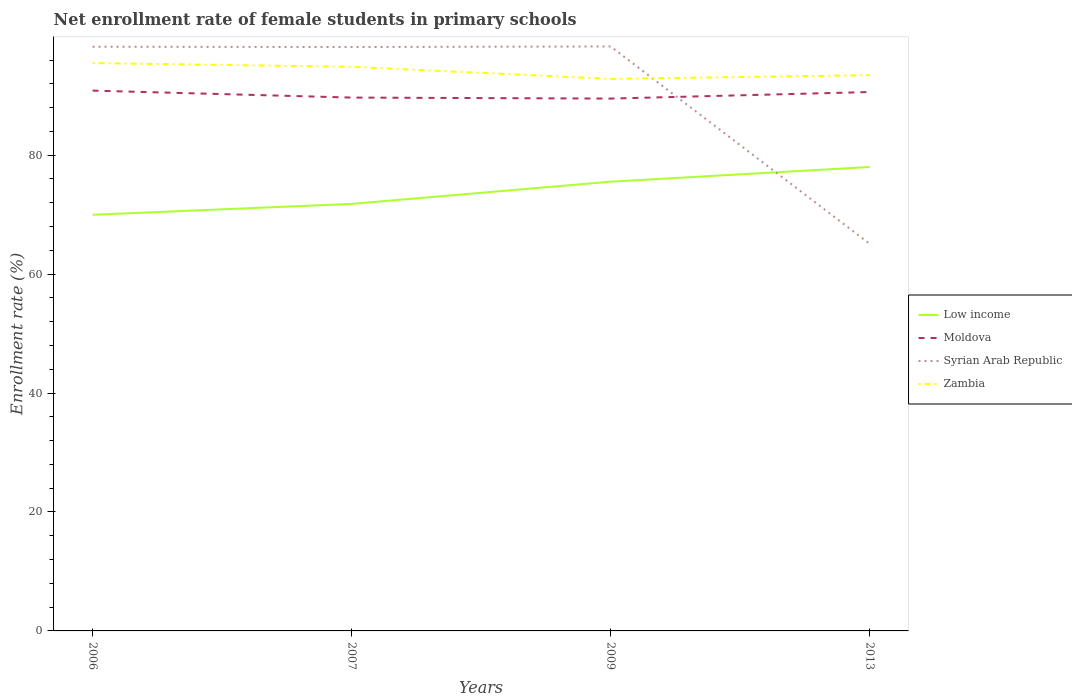Across all years, what is the maximum net enrollment rate of female students in primary schools in Zambia?
Provide a succinct answer. 92.83. In which year was the net enrollment rate of female students in primary schools in Low income maximum?
Ensure brevity in your answer.  2006. What is the total net enrollment rate of female students in primary schools in Moldova in the graph?
Keep it short and to the point. -1.1. What is the difference between the highest and the second highest net enrollment rate of female students in primary schools in Low income?
Provide a succinct answer. 8.03. What is the difference between the highest and the lowest net enrollment rate of female students in primary schools in Syrian Arab Republic?
Your answer should be compact. 3. Is the net enrollment rate of female students in primary schools in Moldova strictly greater than the net enrollment rate of female students in primary schools in Syrian Arab Republic over the years?
Offer a terse response. No. How many lines are there?
Ensure brevity in your answer.  4. What is the difference between two consecutive major ticks on the Y-axis?
Make the answer very short. 20. Does the graph contain any zero values?
Ensure brevity in your answer.  No. Does the graph contain grids?
Offer a very short reply. No. How many legend labels are there?
Give a very brief answer. 4. What is the title of the graph?
Give a very brief answer. Net enrollment rate of female students in primary schools. What is the label or title of the X-axis?
Your answer should be compact. Years. What is the label or title of the Y-axis?
Ensure brevity in your answer.  Enrollment rate (%). What is the Enrollment rate (%) of Low income in 2006?
Give a very brief answer. 69.98. What is the Enrollment rate (%) of Moldova in 2006?
Offer a terse response. 90.86. What is the Enrollment rate (%) in Syrian Arab Republic in 2006?
Make the answer very short. 98.23. What is the Enrollment rate (%) in Zambia in 2006?
Ensure brevity in your answer.  95.49. What is the Enrollment rate (%) of Low income in 2007?
Your answer should be compact. 71.81. What is the Enrollment rate (%) of Moldova in 2007?
Your response must be concise. 89.69. What is the Enrollment rate (%) in Syrian Arab Republic in 2007?
Your response must be concise. 98.18. What is the Enrollment rate (%) in Zambia in 2007?
Ensure brevity in your answer.  94.86. What is the Enrollment rate (%) in Low income in 2009?
Your answer should be compact. 75.54. What is the Enrollment rate (%) of Moldova in 2009?
Offer a very short reply. 89.52. What is the Enrollment rate (%) of Syrian Arab Republic in 2009?
Make the answer very short. 98.28. What is the Enrollment rate (%) in Zambia in 2009?
Give a very brief answer. 92.83. What is the Enrollment rate (%) of Low income in 2013?
Provide a short and direct response. 78.01. What is the Enrollment rate (%) in Moldova in 2013?
Ensure brevity in your answer.  90.62. What is the Enrollment rate (%) of Syrian Arab Republic in 2013?
Your answer should be very brief. 65.09. What is the Enrollment rate (%) of Zambia in 2013?
Provide a succinct answer. 93.46. Across all years, what is the maximum Enrollment rate (%) of Low income?
Your answer should be very brief. 78.01. Across all years, what is the maximum Enrollment rate (%) in Moldova?
Offer a very short reply. 90.86. Across all years, what is the maximum Enrollment rate (%) of Syrian Arab Republic?
Make the answer very short. 98.28. Across all years, what is the maximum Enrollment rate (%) of Zambia?
Offer a very short reply. 95.49. Across all years, what is the minimum Enrollment rate (%) in Low income?
Offer a very short reply. 69.98. Across all years, what is the minimum Enrollment rate (%) of Moldova?
Give a very brief answer. 89.52. Across all years, what is the minimum Enrollment rate (%) of Syrian Arab Republic?
Your answer should be very brief. 65.09. Across all years, what is the minimum Enrollment rate (%) in Zambia?
Your answer should be compact. 92.83. What is the total Enrollment rate (%) in Low income in the graph?
Ensure brevity in your answer.  295.34. What is the total Enrollment rate (%) of Moldova in the graph?
Offer a very short reply. 360.67. What is the total Enrollment rate (%) in Syrian Arab Republic in the graph?
Offer a terse response. 359.79. What is the total Enrollment rate (%) in Zambia in the graph?
Make the answer very short. 376.64. What is the difference between the Enrollment rate (%) in Low income in 2006 and that in 2007?
Your answer should be compact. -1.83. What is the difference between the Enrollment rate (%) of Moldova in 2006 and that in 2007?
Make the answer very short. 1.17. What is the difference between the Enrollment rate (%) in Syrian Arab Republic in 2006 and that in 2007?
Your answer should be very brief. 0.05. What is the difference between the Enrollment rate (%) in Zambia in 2006 and that in 2007?
Make the answer very short. 0.64. What is the difference between the Enrollment rate (%) in Low income in 2006 and that in 2009?
Offer a very short reply. -5.56. What is the difference between the Enrollment rate (%) of Moldova in 2006 and that in 2009?
Offer a very short reply. 1.34. What is the difference between the Enrollment rate (%) in Syrian Arab Republic in 2006 and that in 2009?
Make the answer very short. -0.05. What is the difference between the Enrollment rate (%) of Zambia in 2006 and that in 2009?
Your answer should be compact. 2.67. What is the difference between the Enrollment rate (%) in Low income in 2006 and that in 2013?
Your answer should be compact. -8.03. What is the difference between the Enrollment rate (%) of Moldova in 2006 and that in 2013?
Provide a succinct answer. 0.24. What is the difference between the Enrollment rate (%) in Syrian Arab Republic in 2006 and that in 2013?
Provide a short and direct response. 33.14. What is the difference between the Enrollment rate (%) of Zambia in 2006 and that in 2013?
Your response must be concise. 2.04. What is the difference between the Enrollment rate (%) in Low income in 2007 and that in 2009?
Offer a very short reply. -3.74. What is the difference between the Enrollment rate (%) of Moldova in 2007 and that in 2009?
Your answer should be compact. 0.17. What is the difference between the Enrollment rate (%) in Syrian Arab Republic in 2007 and that in 2009?
Provide a succinct answer. -0.1. What is the difference between the Enrollment rate (%) of Zambia in 2007 and that in 2009?
Offer a very short reply. 2.03. What is the difference between the Enrollment rate (%) of Low income in 2007 and that in 2013?
Give a very brief answer. -6.21. What is the difference between the Enrollment rate (%) in Moldova in 2007 and that in 2013?
Give a very brief answer. -0.93. What is the difference between the Enrollment rate (%) in Syrian Arab Republic in 2007 and that in 2013?
Keep it short and to the point. 33.09. What is the difference between the Enrollment rate (%) in Zambia in 2007 and that in 2013?
Provide a succinct answer. 1.4. What is the difference between the Enrollment rate (%) of Low income in 2009 and that in 2013?
Keep it short and to the point. -2.47. What is the difference between the Enrollment rate (%) in Moldova in 2009 and that in 2013?
Provide a succinct answer. -1.1. What is the difference between the Enrollment rate (%) of Syrian Arab Republic in 2009 and that in 2013?
Give a very brief answer. 33.19. What is the difference between the Enrollment rate (%) in Zambia in 2009 and that in 2013?
Make the answer very short. -0.63. What is the difference between the Enrollment rate (%) in Low income in 2006 and the Enrollment rate (%) in Moldova in 2007?
Provide a short and direct response. -19.71. What is the difference between the Enrollment rate (%) of Low income in 2006 and the Enrollment rate (%) of Syrian Arab Republic in 2007?
Provide a short and direct response. -28.2. What is the difference between the Enrollment rate (%) in Low income in 2006 and the Enrollment rate (%) in Zambia in 2007?
Your answer should be compact. -24.88. What is the difference between the Enrollment rate (%) of Moldova in 2006 and the Enrollment rate (%) of Syrian Arab Republic in 2007?
Your response must be concise. -7.33. What is the difference between the Enrollment rate (%) of Moldova in 2006 and the Enrollment rate (%) of Zambia in 2007?
Provide a short and direct response. -4. What is the difference between the Enrollment rate (%) of Syrian Arab Republic in 2006 and the Enrollment rate (%) of Zambia in 2007?
Offer a terse response. 3.38. What is the difference between the Enrollment rate (%) in Low income in 2006 and the Enrollment rate (%) in Moldova in 2009?
Ensure brevity in your answer.  -19.54. What is the difference between the Enrollment rate (%) of Low income in 2006 and the Enrollment rate (%) of Syrian Arab Republic in 2009?
Ensure brevity in your answer.  -28.3. What is the difference between the Enrollment rate (%) of Low income in 2006 and the Enrollment rate (%) of Zambia in 2009?
Ensure brevity in your answer.  -22.85. What is the difference between the Enrollment rate (%) in Moldova in 2006 and the Enrollment rate (%) in Syrian Arab Republic in 2009?
Your answer should be very brief. -7.43. What is the difference between the Enrollment rate (%) of Moldova in 2006 and the Enrollment rate (%) of Zambia in 2009?
Provide a short and direct response. -1.97. What is the difference between the Enrollment rate (%) of Syrian Arab Republic in 2006 and the Enrollment rate (%) of Zambia in 2009?
Give a very brief answer. 5.41. What is the difference between the Enrollment rate (%) in Low income in 2006 and the Enrollment rate (%) in Moldova in 2013?
Make the answer very short. -20.64. What is the difference between the Enrollment rate (%) in Low income in 2006 and the Enrollment rate (%) in Syrian Arab Republic in 2013?
Your answer should be very brief. 4.89. What is the difference between the Enrollment rate (%) in Low income in 2006 and the Enrollment rate (%) in Zambia in 2013?
Give a very brief answer. -23.48. What is the difference between the Enrollment rate (%) in Moldova in 2006 and the Enrollment rate (%) in Syrian Arab Republic in 2013?
Provide a succinct answer. 25.76. What is the difference between the Enrollment rate (%) of Moldova in 2006 and the Enrollment rate (%) of Zambia in 2013?
Offer a very short reply. -2.6. What is the difference between the Enrollment rate (%) in Syrian Arab Republic in 2006 and the Enrollment rate (%) in Zambia in 2013?
Make the answer very short. 4.78. What is the difference between the Enrollment rate (%) of Low income in 2007 and the Enrollment rate (%) of Moldova in 2009?
Keep it short and to the point. -17.71. What is the difference between the Enrollment rate (%) in Low income in 2007 and the Enrollment rate (%) in Syrian Arab Republic in 2009?
Make the answer very short. -26.48. What is the difference between the Enrollment rate (%) in Low income in 2007 and the Enrollment rate (%) in Zambia in 2009?
Offer a very short reply. -21.02. What is the difference between the Enrollment rate (%) in Moldova in 2007 and the Enrollment rate (%) in Syrian Arab Republic in 2009?
Your answer should be very brief. -8.6. What is the difference between the Enrollment rate (%) of Moldova in 2007 and the Enrollment rate (%) of Zambia in 2009?
Your answer should be very brief. -3.14. What is the difference between the Enrollment rate (%) of Syrian Arab Republic in 2007 and the Enrollment rate (%) of Zambia in 2009?
Give a very brief answer. 5.36. What is the difference between the Enrollment rate (%) of Low income in 2007 and the Enrollment rate (%) of Moldova in 2013?
Your answer should be compact. -18.81. What is the difference between the Enrollment rate (%) in Low income in 2007 and the Enrollment rate (%) in Syrian Arab Republic in 2013?
Offer a terse response. 6.72. What is the difference between the Enrollment rate (%) of Low income in 2007 and the Enrollment rate (%) of Zambia in 2013?
Ensure brevity in your answer.  -21.65. What is the difference between the Enrollment rate (%) of Moldova in 2007 and the Enrollment rate (%) of Syrian Arab Republic in 2013?
Ensure brevity in your answer.  24.59. What is the difference between the Enrollment rate (%) in Moldova in 2007 and the Enrollment rate (%) in Zambia in 2013?
Ensure brevity in your answer.  -3.77. What is the difference between the Enrollment rate (%) in Syrian Arab Republic in 2007 and the Enrollment rate (%) in Zambia in 2013?
Offer a terse response. 4.73. What is the difference between the Enrollment rate (%) in Low income in 2009 and the Enrollment rate (%) in Moldova in 2013?
Offer a terse response. -15.07. What is the difference between the Enrollment rate (%) in Low income in 2009 and the Enrollment rate (%) in Syrian Arab Republic in 2013?
Provide a succinct answer. 10.45. What is the difference between the Enrollment rate (%) of Low income in 2009 and the Enrollment rate (%) of Zambia in 2013?
Give a very brief answer. -17.91. What is the difference between the Enrollment rate (%) in Moldova in 2009 and the Enrollment rate (%) in Syrian Arab Republic in 2013?
Provide a succinct answer. 24.42. What is the difference between the Enrollment rate (%) in Moldova in 2009 and the Enrollment rate (%) in Zambia in 2013?
Make the answer very short. -3.94. What is the difference between the Enrollment rate (%) in Syrian Arab Republic in 2009 and the Enrollment rate (%) in Zambia in 2013?
Offer a very short reply. 4.83. What is the average Enrollment rate (%) of Low income per year?
Offer a terse response. 73.84. What is the average Enrollment rate (%) in Moldova per year?
Make the answer very short. 90.17. What is the average Enrollment rate (%) of Syrian Arab Republic per year?
Keep it short and to the point. 89.95. What is the average Enrollment rate (%) in Zambia per year?
Ensure brevity in your answer.  94.16. In the year 2006, what is the difference between the Enrollment rate (%) in Low income and Enrollment rate (%) in Moldova?
Provide a succinct answer. -20.88. In the year 2006, what is the difference between the Enrollment rate (%) of Low income and Enrollment rate (%) of Syrian Arab Republic?
Keep it short and to the point. -28.25. In the year 2006, what is the difference between the Enrollment rate (%) of Low income and Enrollment rate (%) of Zambia?
Offer a very short reply. -25.51. In the year 2006, what is the difference between the Enrollment rate (%) in Moldova and Enrollment rate (%) in Syrian Arab Republic?
Offer a very short reply. -7.38. In the year 2006, what is the difference between the Enrollment rate (%) of Moldova and Enrollment rate (%) of Zambia?
Your answer should be very brief. -4.64. In the year 2006, what is the difference between the Enrollment rate (%) of Syrian Arab Republic and Enrollment rate (%) of Zambia?
Provide a short and direct response. 2.74. In the year 2007, what is the difference between the Enrollment rate (%) of Low income and Enrollment rate (%) of Moldova?
Offer a terse response. -17.88. In the year 2007, what is the difference between the Enrollment rate (%) of Low income and Enrollment rate (%) of Syrian Arab Republic?
Offer a terse response. -26.38. In the year 2007, what is the difference between the Enrollment rate (%) in Low income and Enrollment rate (%) in Zambia?
Offer a very short reply. -23.05. In the year 2007, what is the difference between the Enrollment rate (%) of Moldova and Enrollment rate (%) of Syrian Arab Republic?
Your response must be concise. -8.5. In the year 2007, what is the difference between the Enrollment rate (%) in Moldova and Enrollment rate (%) in Zambia?
Keep it short and to the point. -5.17. In the year 2007, what is the difference between the Enrollment rate (%) of Syrian Arab Republic and Enrollment rate (%) of Zambia?
Keep it short and to the point. 3.33. In the year 2009, what is the difference between the Enrollment rate (%) of Low income and Enrollment rate (%) of Moldova?
Provide a succinct answer. -13.97. In the year 2009, what is the difference between the Enrollment rate (%) in Low income and Enrollment rate (%) in Syrian Arab Republic?
Your answer should be compact. -22.74. In the year 2009, what is the difference between the Enrollment rate (%) of Low income and Enrollment rate (%) of Zambia?
Provide a succinct answer. -17.29. In the year 2009, what is the difference between the Enrollment rate (%) of Moldova and Enrollment rate (%) of Syrian Arab Republic?
Provide a succinct answer. -8.77. In the year 2009, what is the difference between the Enrollment rate (%) of Moldova and Enrollment rate (%) of Zambia?
Your answer should be compact. -3.31. In the year 2009, what is the difference between the Enrollment rate (%) of Syrian Arab Republic and Enrollment rate (%) of Zambia?
Make the answer very short. 5.46. In the year 2013, what is the difference between the Enrollment rate (%) in Low income and Enrollment rate (%) in Moldova?
Offer a terse response. -12.6. In the year 2013, what is the difference between the Enrollment rate (%) of Low income and Enrollment rate (%) of Syrian Arab Republic?
Your answer should be very brief. 12.92. In the year 2013, what is the difference between the Enrollment rate (%) of Low income and Enrollment rate (%) of Zambia?
Make the answer very short. -15.44. In the year 2013, what is the difference between the Enrollment rate (%) of Moldova and Enrollment rate (%) of Syrian Arab Republic?
Offer a very short reply. 25.52. In the year 2013, what is the difference between the Enrollment rate (%) in Moldova and Enrollment rate (%) in Zambia?
Ensure brevity in your answer.  -2.84. In the year 2013, what is the difference between the Enrollment rate (%) in Syrian Arab Republic and Enrollment rate (%) in Zambia?
Your answer should be compact. -28.37. What is the ratio of the Enrollment rate (%) of Low income in 2006 to that in 2007?
Ensure brevity in your answer.  0.97. What is the ratio of the Enrollment rate (%) of Zambia in 2006 to that in 2007?
Offer a terse response. 1.01. What is the ratio of the Enrollment rate (%) in Low income in 2006 to that in 2009?
Keep it short and to the point. 0.93. What is the ratio of the Enrollment rate (%) in Zambia in 2006 to that in 2009?
Provide a short and direct response. 1.03. What is the ratio of the Enrollment rate (%) in Low income in 2006 to that in 2013?
Keep it short and to the point. 0.9. What is the ratio of the Enrollment rate (%) of Syrian Arab Republic in 2006 to that in 2013?
Make the answer very short. 1.51. What is the ratio of the Enrollment rate (%) of Zambia in 2006 to that in 2013?
Provide a succinct answer. 1.02. What is the ratio of the Enrollment rate (%) of Low income in 2007 to that in 2009?
Give a very brief answer. 0.95. What is the ratio of the Enrollment rate (%) of Zambia in 2007 to that in 2009?
Make the answer very short. 1.02. What is the ratio of the Enrollment rate (%) of Low income in 2007 to that in 2013?
Provide a short and direct response. 0.92. What is the ratio of the Enrollment rate (%) in Syrian Arab Republic in 2007 to that in 2013?
Your answer should be compact. 1.51. What is the ratio of the Enrollment rate (%) in Low income in 2009 to that in 2013?
Make the answer very short. 0.97. What is the ratio of the Enrollment rate (%) in Moldova in 2009 to that in 2013?
Your answer should be compact. 0.99. What is the ratio of the Enrollment rate (%) in Syrian Arab Republic in 2009 to that in 2013?
Your response must be concise. 1.51. What is the difference between the highest and the second highest Enrollment rate (%) in Low income?
Give a very brief answer. 2.47. What is the difference between the highest and the second highest Enrollment rate (%) in Moldova?
Ensure brevity in your answer.  0.24. What is the difference between the highest and the second highest Enrollment rate (%) in Syrian Arab Republic?
Offer a very short reply. 0.05. What is the difference between the highest and the second highest Enrollment rate (%) in Zambia?
Keep it short and to the point. 0.64. What is the difference between the highest and the lowest Enrollment rate (%) of Low income?
Provide a succinct answer. 8.03. What is the difference between the highest and the lowest Enrollment rate (%) in Moldova?
Make the answer very short. 1.34. What is the difference between the highest and the lowest Enrollment rate (%) in Syrian Arab Republic?
Keep it short and to the point. 33.19. What is the difference between the highest and the lowest Enrollment rate (%) of Zambia?
Ensure brevity in your answer.  2.67. 